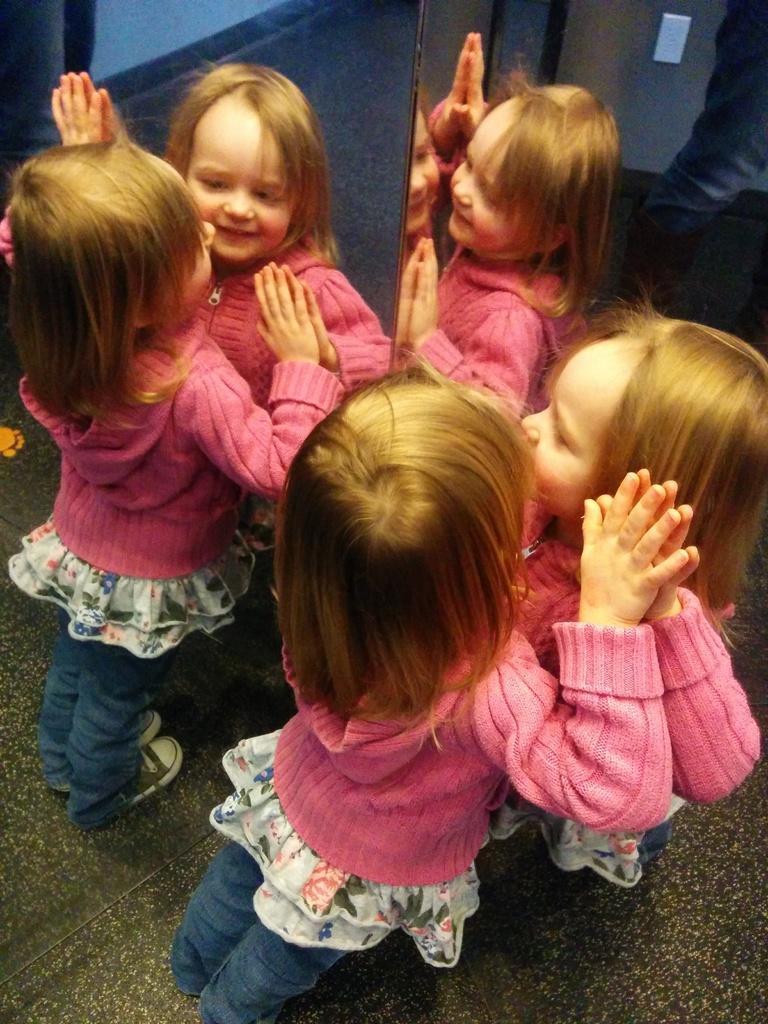Can you describe this image briefly? In this image I can see a child wearing pink, white and blue colored dress is standing and I can see mirrors around her. In the mirrors I can see the reflections of the child. 